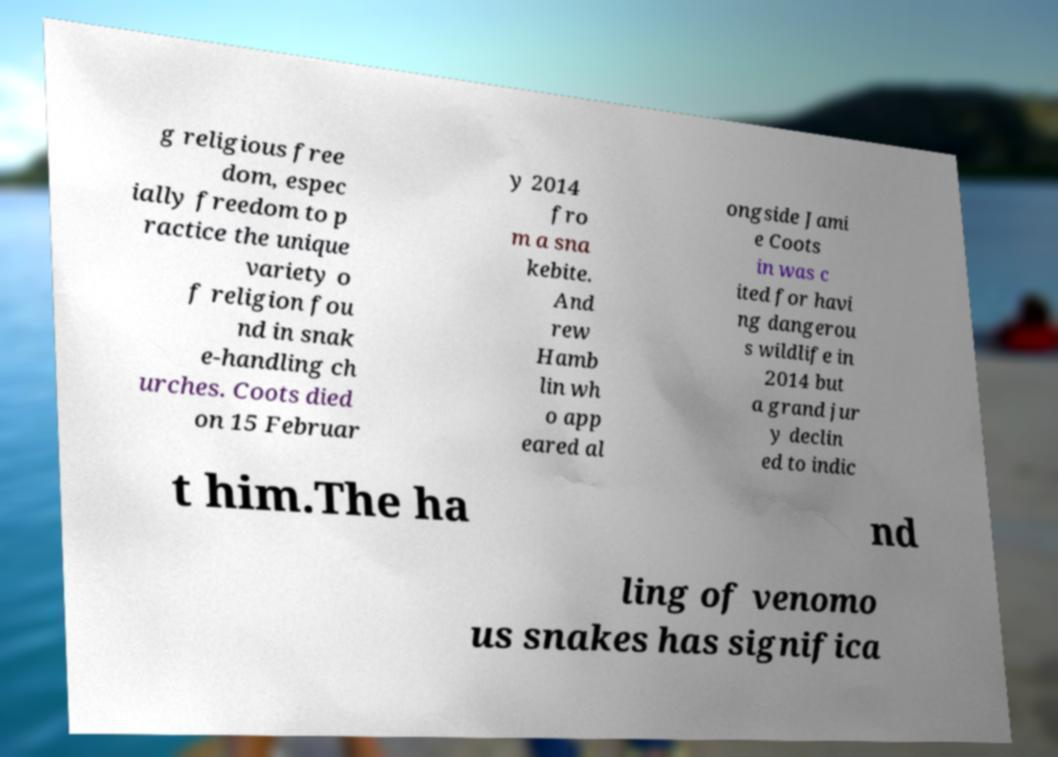Can you read and provide the text displayed in the image?This photo seems to have some interesting text. Can you extract and type it out for me? g religious free dom, espec ially freedom to p ractice the unique variety o f religion fou nd in snak e-handling ch urches. Coots died on 15 Februar y 2014 fro m a sna kebite. And rew Hamb lin wh o app eared al ongside Jami e Coots in was c ited for havi ng dangerou s wildlife in 2014 but a grand jur y declin ed to indic t him.The ha nd ling of venomo us snakes has significa 